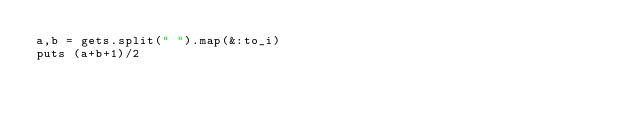<code> <loc_0><loc_0><loc_500><loc_500><_Ruby_>a,b = gets.split(" ").map(&:to_i)
puts (a+b+1)/2</code> 